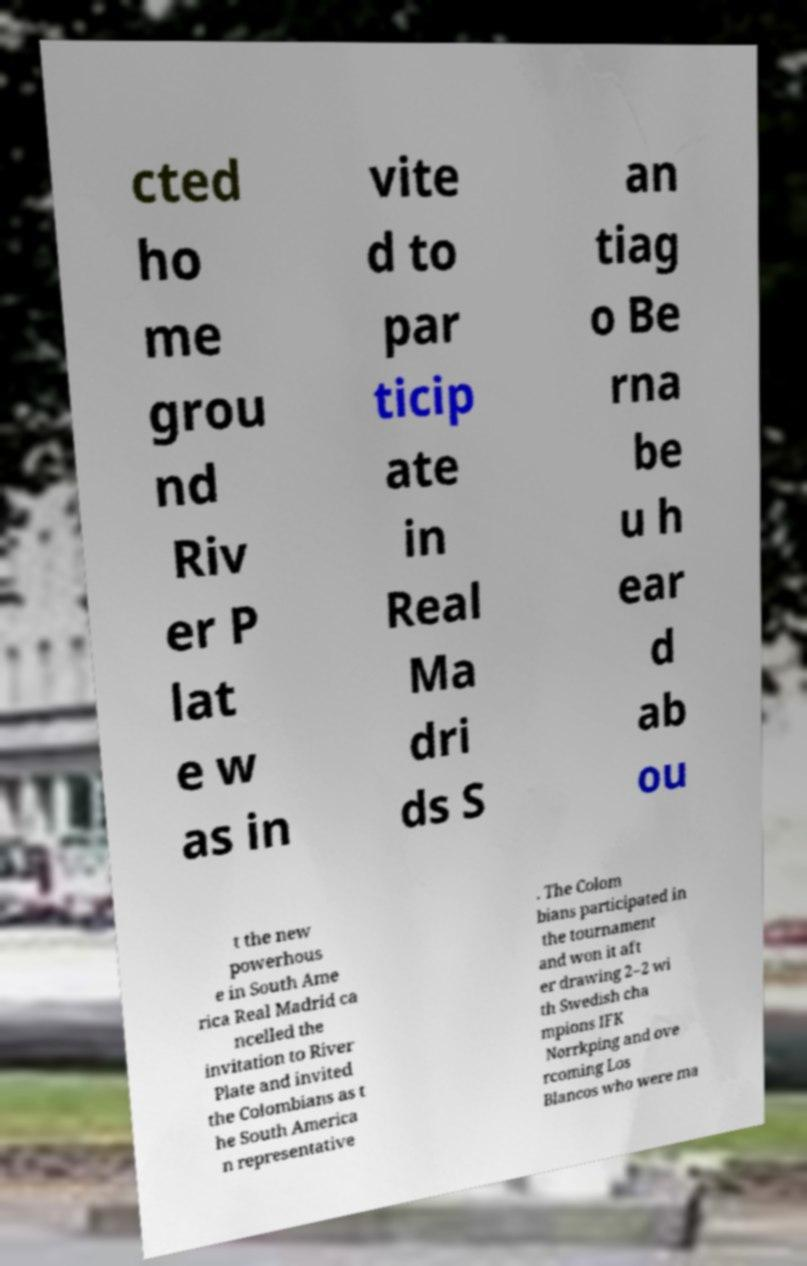Can you accurately transcribe the text from the provided image for me? cted ho me grou nd Riv er P lat e w as in vite d to par ticip ate in Real Ma dri ds S an tiag o Be rna be u h ear d ab ou t the new powerhous e in South Ame rica Real Madrid ca ncelled the invitation to River Plate and invited the Colombians as t he South America n representative . The Colom bians participated in the tournament and won it aft er drawing 2–2 wi th Swedish cha mpions IFK Norrkping and ove rcoming Los Blancos who were ma 